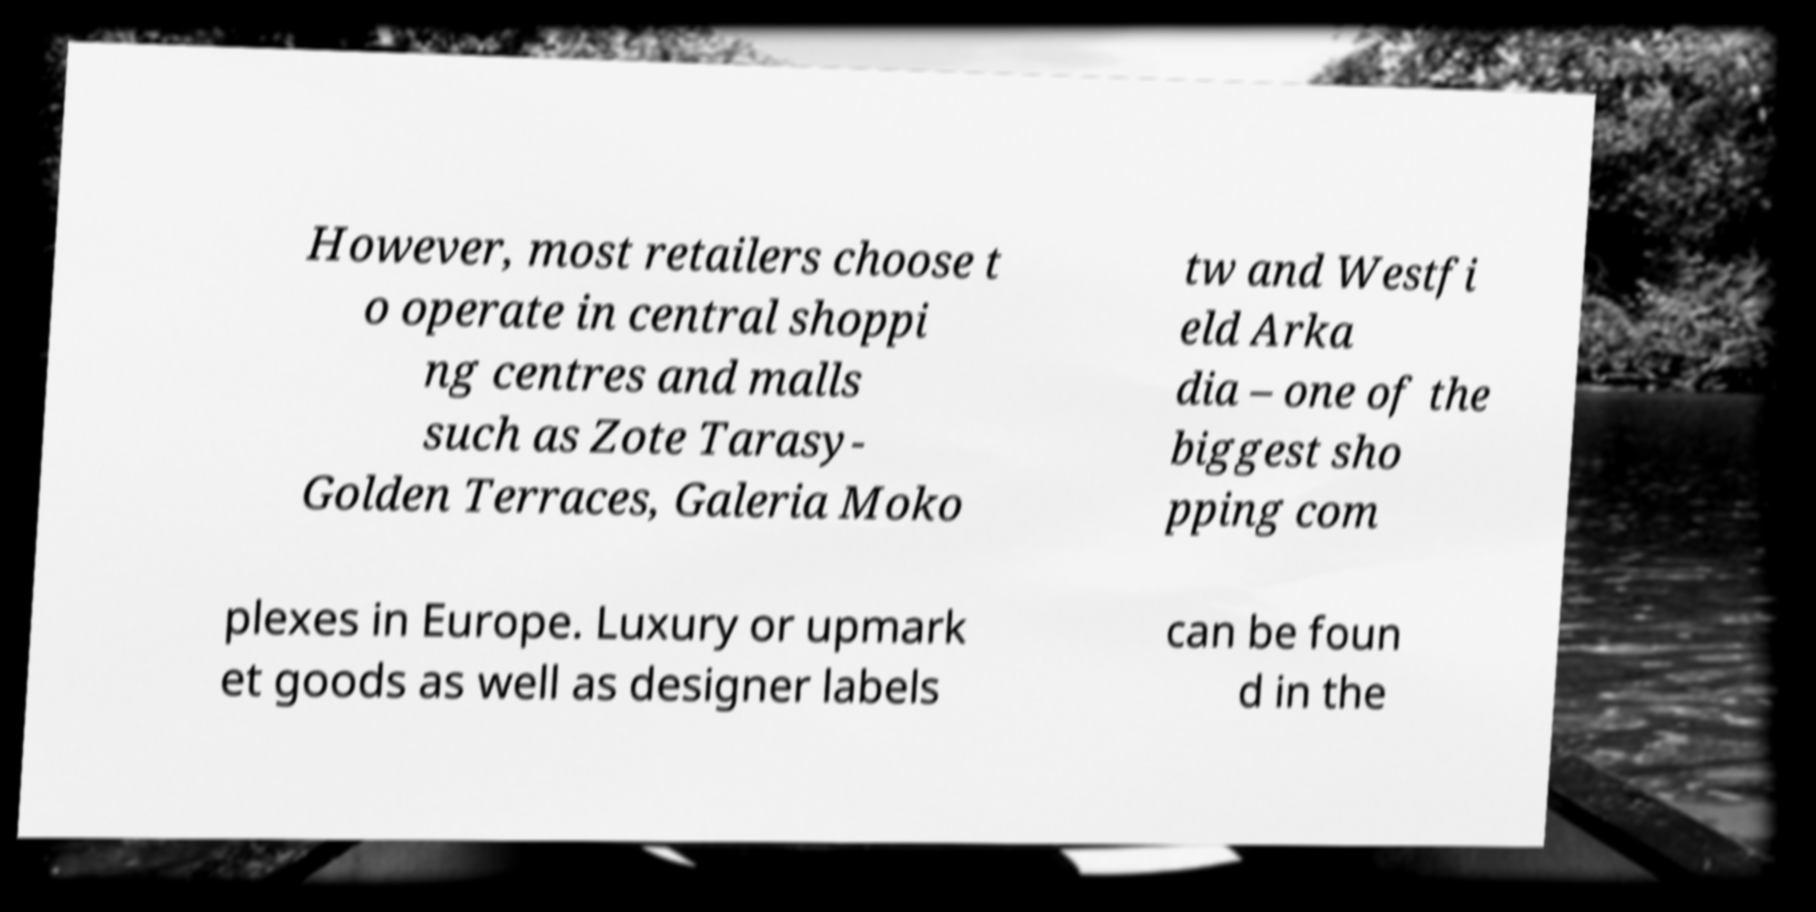There's text embedded in this image that I need extracted. Can you transcribe it verbatim? However, most retailers choose t o operate in central shoppi ng centres and malls such as Zote Tarasy- Golden Terraces, Galeria Moko tw and Westfi eld Arka dia – one of the biggest sho pping com plexes in Europe. Luxury or upmark et goods as well as designer labels can be foun d in the 